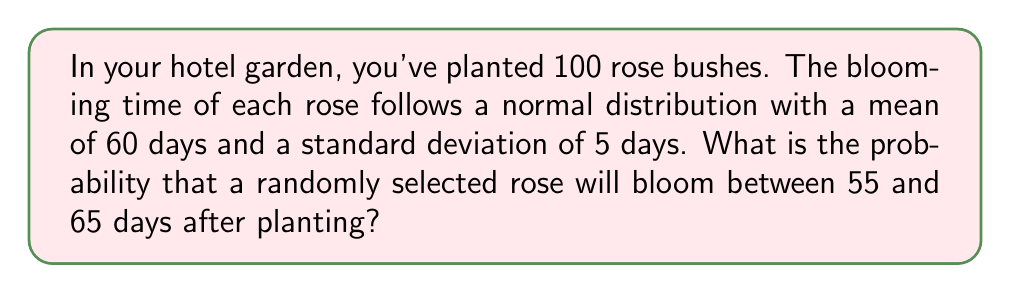Show me your answer to this math problem. To solve this problem, we'll use the properties of the normal distribution and the concept of z-scores.

Step 1: Identify the given information
- Mean (μ) = 60 days
- Standard deviation (σ) = 5 days
- We want the probability of blooming between 55 and 65 days

Step 2: Calculate the z-scores for the lower and upper bounds
For the lower bound (55 days):
$$ z_1 = \frac{x - \mu}{\sigma} = \frac{55 - 60}{5} = -1 $$

For the upper bound (65 days):
$$ z_2 = \frac{x - \mu}{\sigma} = \frac{65 - 60}{5} = 1 $$

Step 3: Use the standard normal distribution table or a calculator to find the area between these z-scores
The probability is equal to the area under the standard normal curve between z = -1 and z = 1.

Using a standard normal table or calculator:
P(-1 ≤ z ≤ 1) = 0.6826

Step 4: Interpret the result
This means that approximately 68.26% of the roses will bloom between 55 and 65 days after planting.
Answer: 0.6826 or 68.26% 